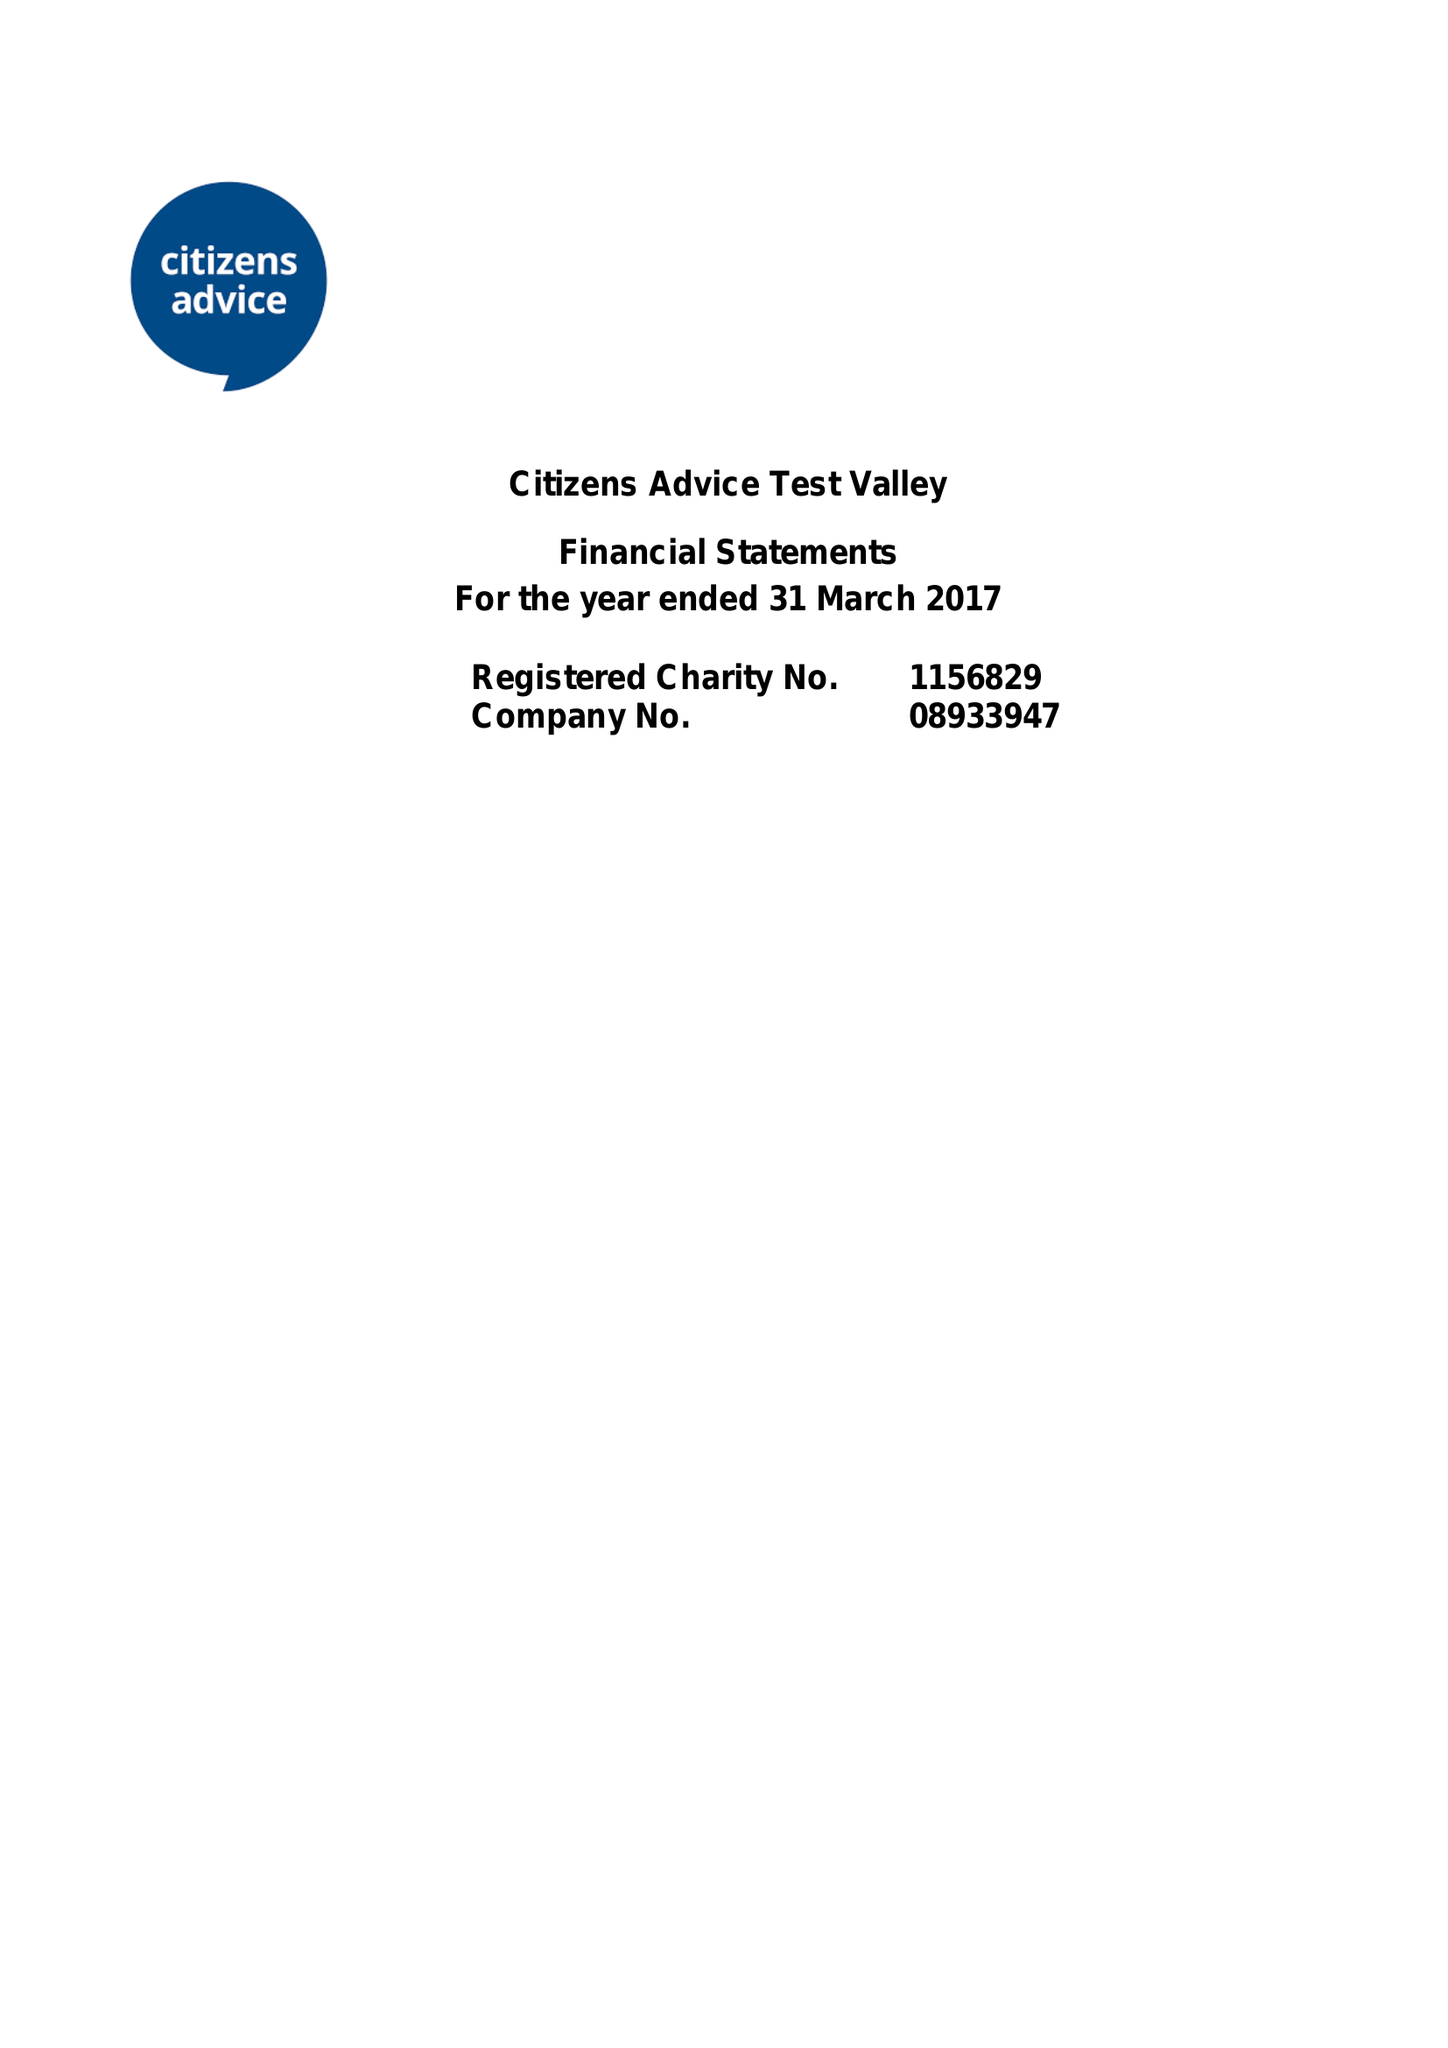What is the value for the address__street_line?
Answer the question using a single word or phrase. 35 LONDON STREET 